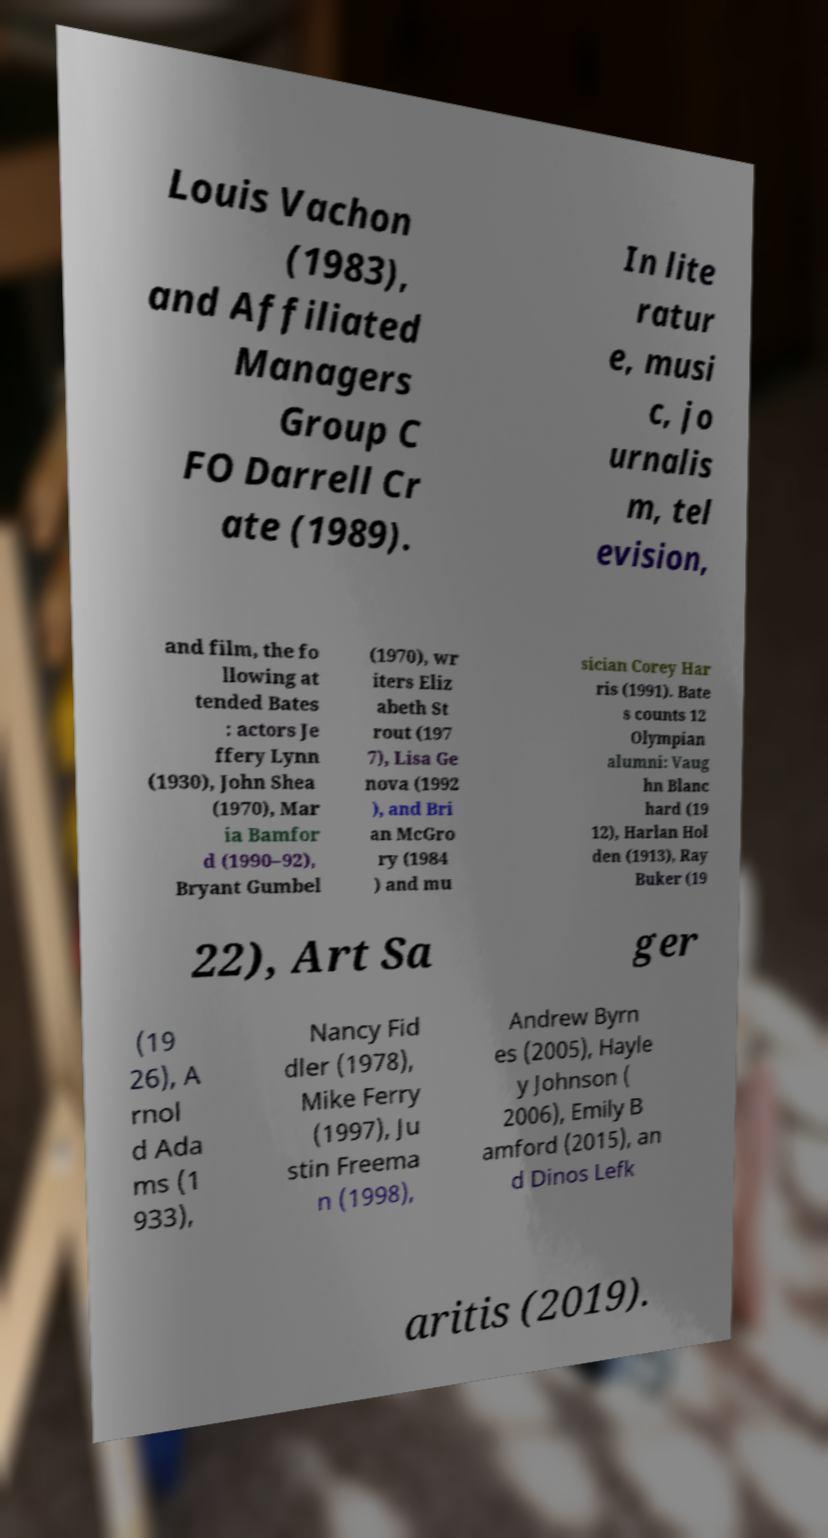Could you assist in decoding the text presented in this image and type it out clearly? Louis Vachon (1983), and Affiliated Managers Group C FO Darrell Cr ate (1989). In lite ratur e, musi c, jo urnalis m, tel evision, and film, the fo llowing at tended Bates : actors Je ffery Lynn (1930), John Shea (1970), Mar ia Bamfor d (1990–92), Bryant Gumbel (1970), wr iters Eliz abeth St rout (197 7), Lisa Ge nova (1992 ), and Bri an McGro ry (1984 ) and mu sician Corey Har ris (1991). Bate s counts 12 Olympian alumni: Vaug hn Blanc hard (19 12), Harlan Hol den (1913), Ray Buker (19 22), Art Sa ger (19 26), A rnol d Ada ms (1 933), Nancy Fid dler (1978), Mike Ferry (1997), Ju stin Freema n (1998), Andrew Byrn es (2005), Hayle y Johnson ( 2006), Emily B amford (2015), an d Dinos Lefk aritis (2019). 